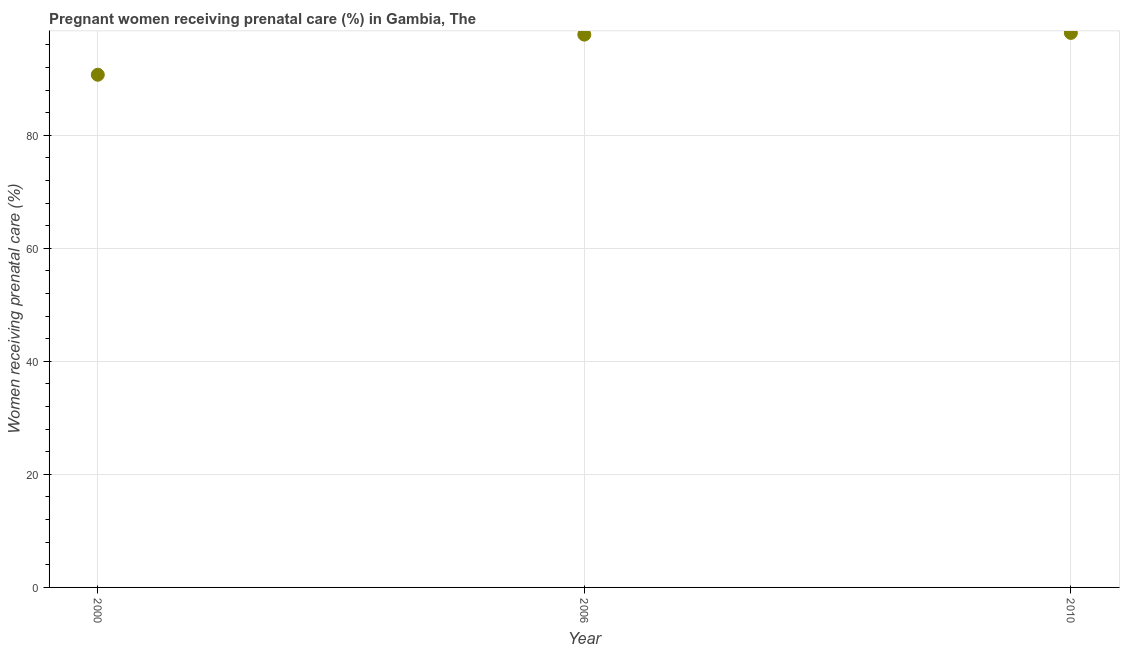What is the percentage of pregnant women receiving prenatal care in 2000?
Ensure brevity in your answer.  90.7. Across all years, what is the maximum percentage of pregnant women receiving prenatal care?
Offer a very short reply. 98.1. Across all years, what is the minimum percentage of pregnant women receiving prenatal care?
Your answer should be very brief. 90.7. What is the sum of the percentage of pregnant women receiving prenatal care?
Give a very brief answer. 286.6. What is the difference between the percentage of pregnant women receiving prenatal care in 2000 and 2010?
Your response must be concise. -7.4. What is the average percentage of pregnant women receiving prenatal care per year?
Provide a short and direct response. 95.53. What is the median percentage of pregnant women receiving prenatal care?
Ensure brevity in your answer.  97.8. Do a majority of the years between 2006 and 2010 (inclusive) have percentage of pregnant women receiving prenatal care greater than 4 %?
Provide a succinct answer. Yes. What is the ratio of the percentage of pregnant women receiving prenatal care in 2000 to that in 2006?
Ensure brevity in your answer.  0.93. What is the difference between the highest and the second highest percentage of pregnant women receiving prenatal care?
Your answer should be very brief. 0.3. What is the difference between the highest and the lowest percentage of pregnant women receiving prenatal care?
Make the answer very short. 7.4. How many years are there in the graph?
Your answer should be compact. 3. What is the difference between two consecutive major ticks on the Y-axis?
Your answer should be very brief. 20. Are the values on the major ticks of Y-axis written in scientific E-notation?
Your answer should be very brief. No. Does the graph contain any zero values?
Keep it short and to the point. No. What is the title of the graph?
Provide a short and direct response. Pregnant women receiving prenatal care (%) in Gambia, The. What is the label or title of the Y-axis?
Provide a short and direct response. Women receiving prenatal care (%). What is the Women receiving prenatal care (%) in 2000?
Ensure brevity in your answer.  90.7. What is the Women receiving prenatal care (%) in 2006?
Make the answer very short. 97.8. What is the Women receiving prenatal care (%) in 2010?
Offer a terse response. 98.1. What is the difference between the Women receiving prenatal care (%) in 2000 and 2010?
Offer a terse response. -7.4. What is the ratio of the Women receiving prenatal care (%) in 2000 to that in 2006?
Provide a succinct answer. 0.93. What is the ratio of the Women receiving prenatal care (%) in 2000 to that in 2010?
Make the answer very short. 0.93. 